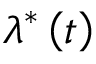Convert formula to latex. <formula><loc_0><loc_0><loc_500><loc_500>\lambda ^ { \ast } \left ( t \right )</formula> 